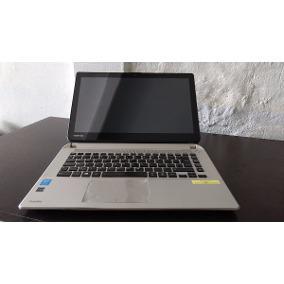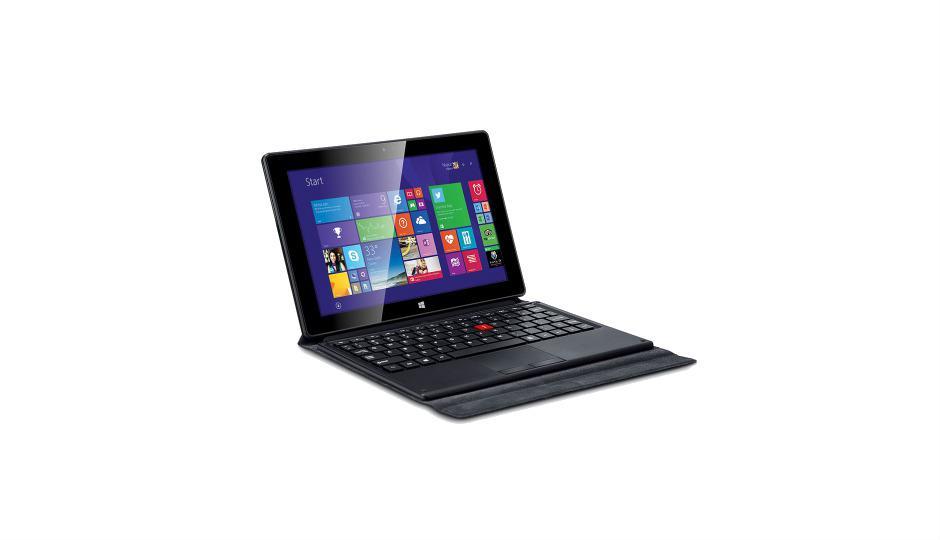The first image is the image on the left, the second image is the image on the right. For the images shown, is this caption "The left image shows a keyboard base separated from the screen, and the right image shows a device with multiple fanned out screens on top of an inverted V base." true? Answer yes or no. No. The first image is the image on the left, the second image is the image on the right. For the images shown, is this caption "The laptop in the image on the right is shown opening is several positions." true? Answer yes or no. No. 